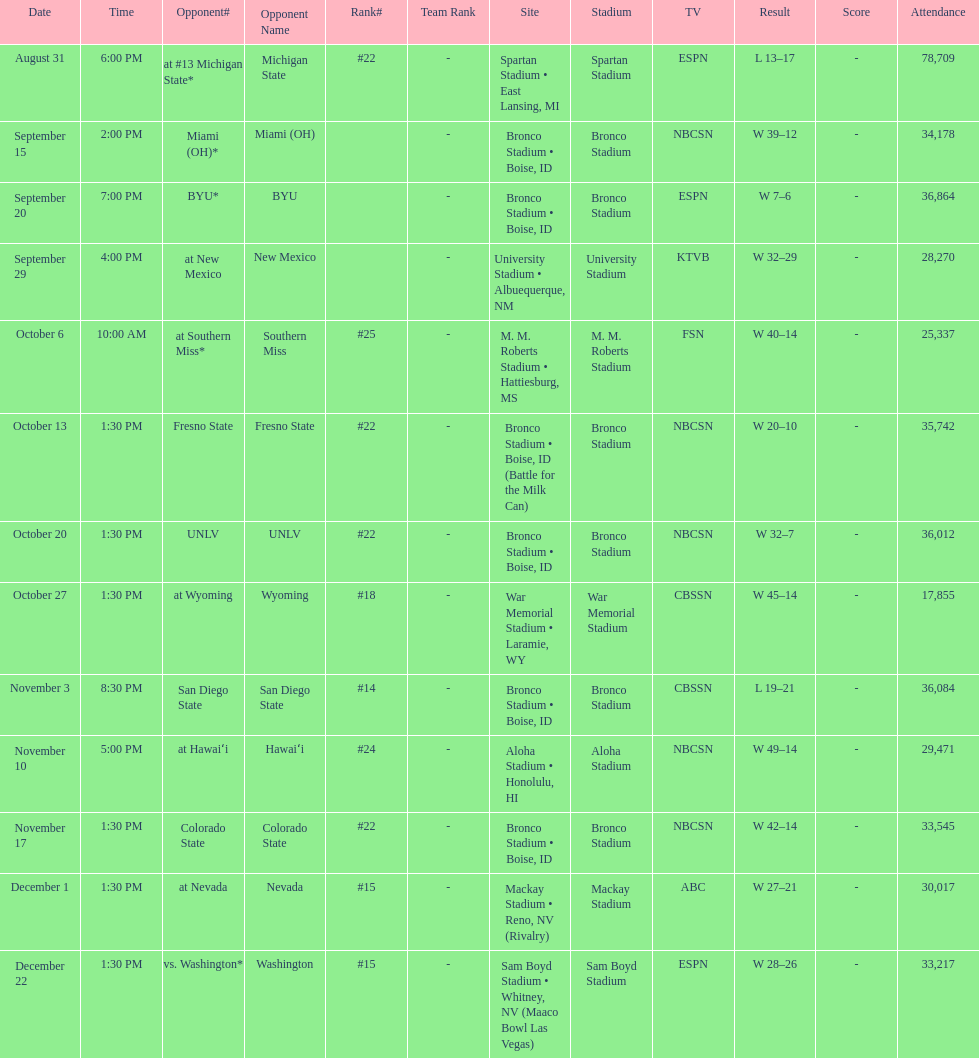What is the score difference for the game against michigan state? 4. 